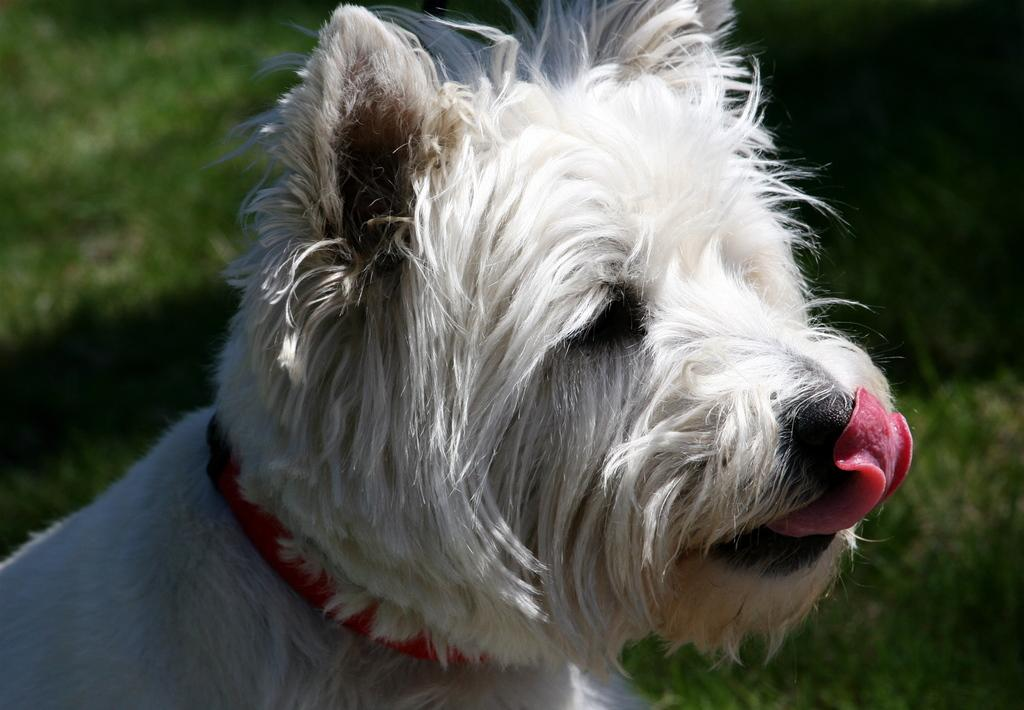What is the main subject in the center of the image? There is a dog in the center of the image. What type of environment is visible in the background of the image? There is grass in the background of the image. How many rings are visible on the dog's tail in the image? There are no rings visible on the dog's tail in the image. What magical process is the dog performing in the image? There is no magical process being performed by the dog in the image. 